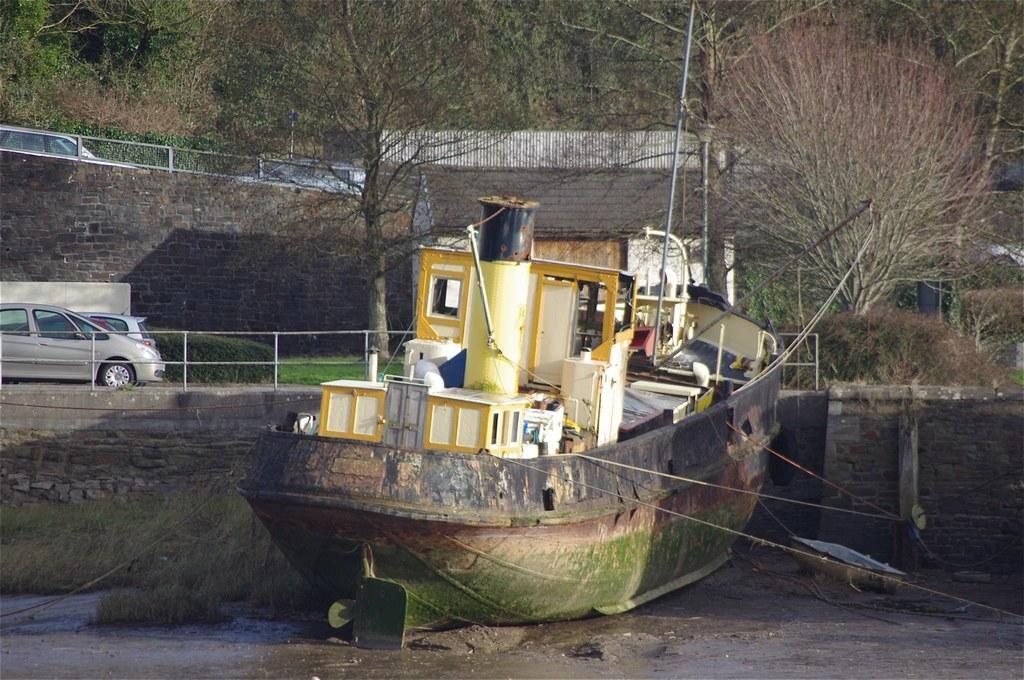Describe this image in one or two sentences. In this image, I can see a boat. These are the ropes, which are tied to the boat. I can see two cars, which are parked. These are the small bushes. I can see the trees. This looks like a wall. I can see two cars. Here is the grass. 